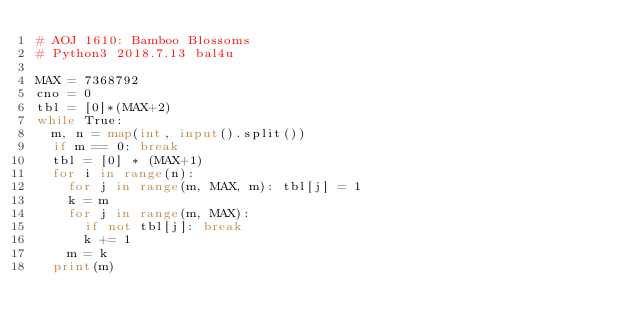Convert code to text. <code><loc_0><loc_0><loc_500><loc_500><_Python_># AOJ 1610: Bamboo Blossoms
# Python3 2018.7.13 bal4u

MAX = 7368792
cno = 0
tbl = [0]*(MAX+2)
while True:
	m, n = map(int, input().split())
	if m == 0: break
	tbl = [0] * (MAX+1)
	for i in range(n):
		for j in range(m, MAX, m): tbl[j] = 1
		k = m
		for j in range(m, MAX):
			if not tbl[j]: break
			k += 1
		m = k
	print(m)

</code> 